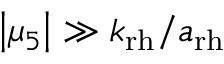<formula> <loc_0><loc_0><loc_500><loc_500>\left | \mu _ { 5 } \right | \gg k _ { r h } / a _ { r h }</formula> 